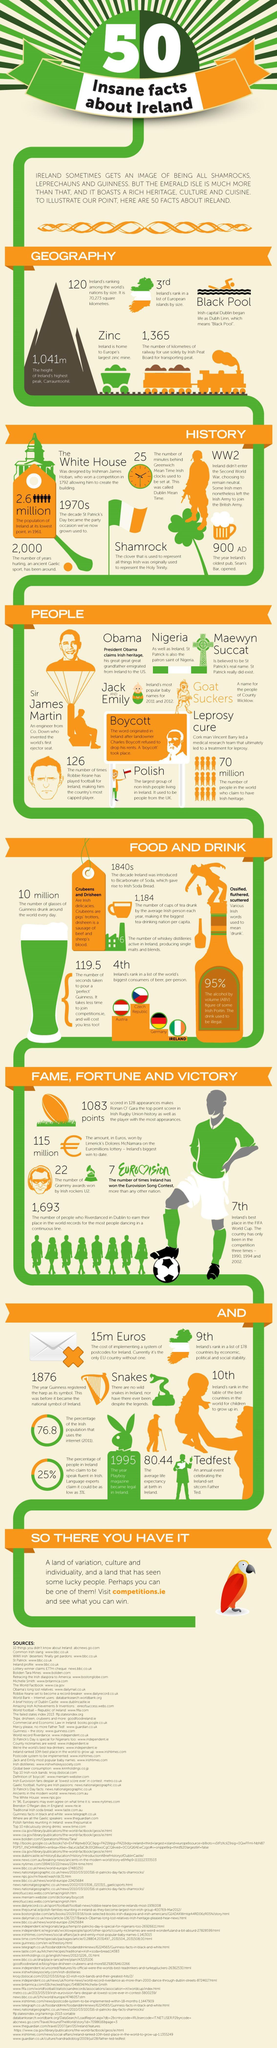Which country ranks third in worlds biggest consumers of beer?
Answer the question with a short phrase. Germany Which metal is found abundantly across Ireland? Zinc What is the rank of Ireland in terms of Land size among other nations? 120 What number of world population has Irish heritage? 70 Million What is Ireland's rank in the list of worlds biggest consumers of beer? 4 What is the total number of Grammy awards won by Irish Rockers U2? 22 What is the capital of Ireland? Dublin Which US President has an Irish origin? Obama The oldest pub in Ireland opened in which year? 900 AD Which country ranks first in worlds biggest consumers of beer? Austria 